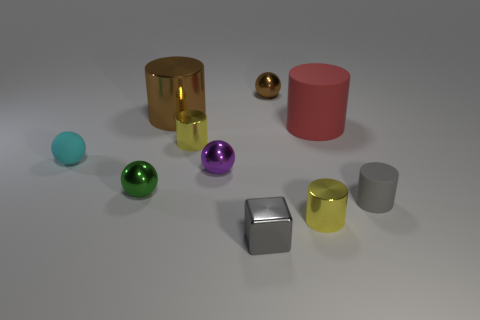There is a small matte object right of the tiny brown metal ball; is there a metallic thing in front of it?
Offer a terse response. Yes. Is the number of gray metal blocks behind the block greater than the number of brown metal cylinders in front of the cyan object?
Your answer should be compact. No. There is a thing that is the same color as the metal block; what material is it?
Offer a very short reply. Rubber. How many big metal cylinders are the same color as the tiny rubber cylinder?
Your answer should be very brief. 0. Do the big cylinder to the left of the brown metallic sphere and the small sphere that is to the right of the tiny purple sphere have the same color?
Give a very brief answer. Yes. Are there any brown spheres left of the matte ball?
Offer a terse response. No. What material is the tiny green thing?
Give a very brief answer. Metal. The big object right of the brown metallic cylinder has what shape?
Provide a succinct answer. Cylinder. Are there any cyan things that have the same size as the brown metal ball?
Provide a short and direct response. Yes. Does the tiny yellow object that is behind the cyan sphere have the same material as the big red thing?
Provide a succinct answer. No. 